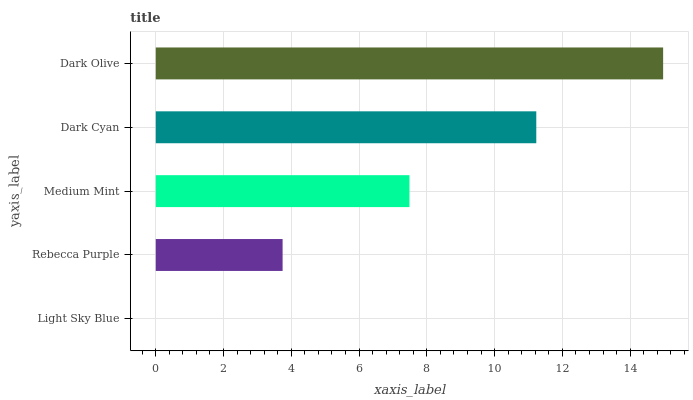Is Light Sky Blue the minimum?
Answer yes or no. Yes. Is Dark Olive the maximum?
Answer yes or no. Yes. Is Rebecca Purple the minimum?
Answer yes or no. No. Is Rebecca Purple the maximum?
Answer yes or no. No. Is Rebecca Purple greater than Light Sky Blue?
Answer yes or no. Yes. Is Light Sky Blue less than Rebecca Purple?
Answer yes or no. Yes. Is Light Sky Blue greater than Rebecca Purple?
Answer yes or no. No. Is Rebecca Purple less than Light Sky Blue?
Answer yes or no. No. Is Medium Mint the high median?
Answer yes or no. Yes. Is Medium Mint the low median?
Answer yes or no. Yes. Is Dark Olive the high median?
Answer yes or no. No. Is Dark Cyan the low median?
Answer yes or no. No. 